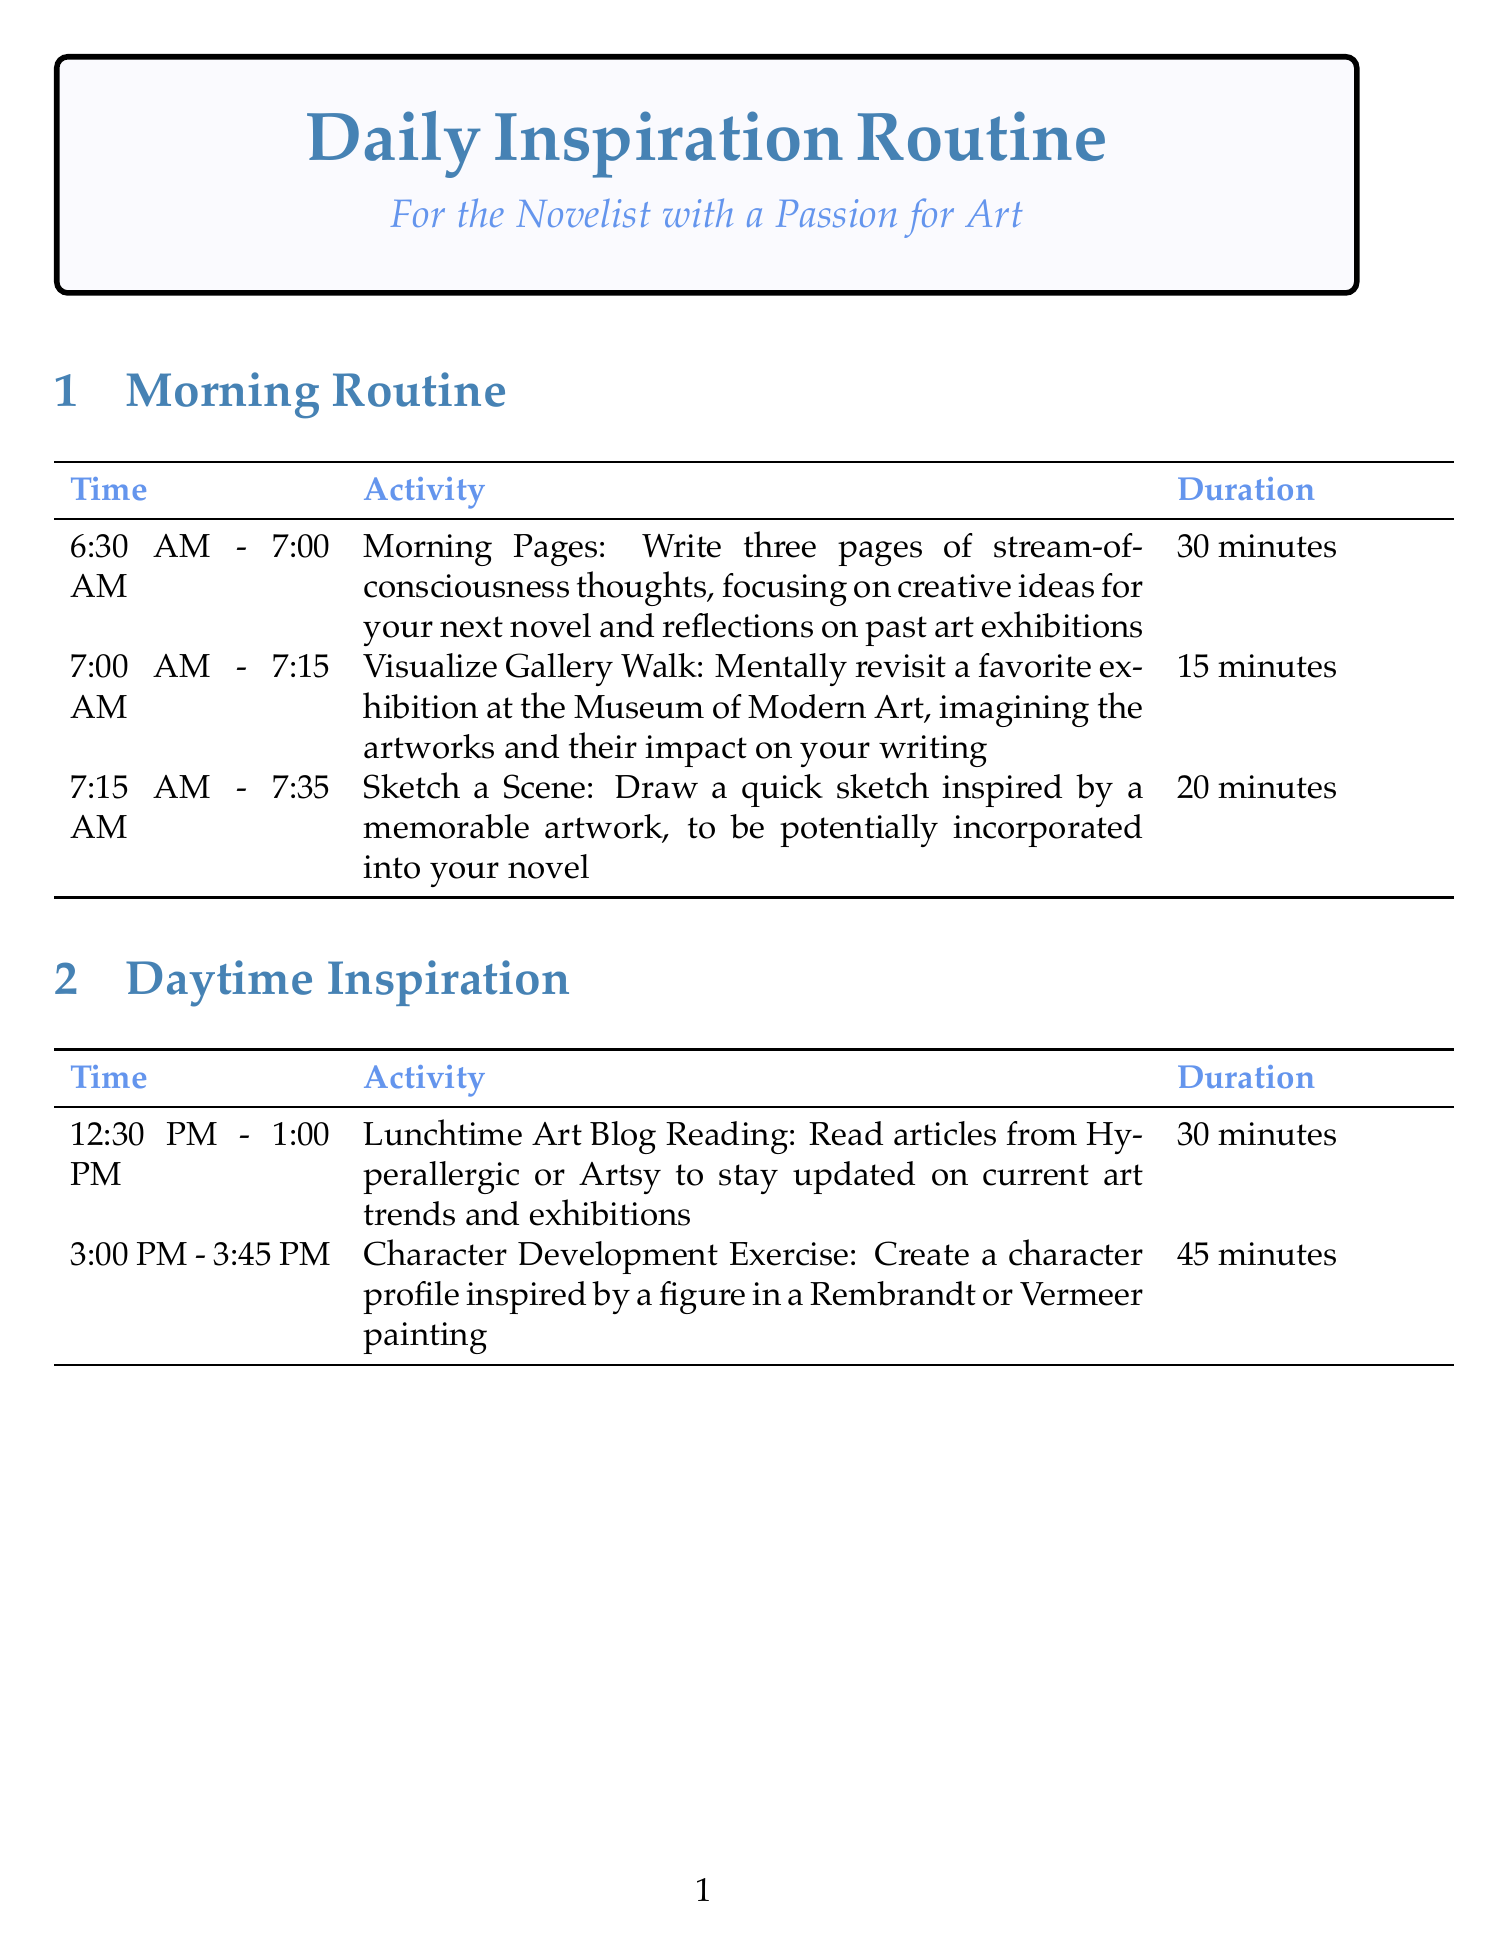What is the duration of Morning Pages? The duration of Morning Pages is specified in the morning routine section of the document as 30 minutes.
Answer: 30 minutes At what time does the Daily Writing Review start? The start time for Daily Writing Review is listed in the evening reflection section of the document.
Answer: 7:00 PM What activity follows Gratitude Journaling? The activity that follows Gratitude Journaling is detailed in the evening reflection section and involves planning.
Answer: Next Day Planning How long is the Virtual Gallery Tour? The duration for the Virtual Gallery Tour is provided in the evening reflection section of the document as 45 minutes.
Answer: 45 minutes What is the total duration of weekly activities? By adding the durations of Local Gallery Visit (2 hours) and Art Book Review (1 hour), the total duration of weekly activities can be found.
Answer: 3 hours Which two paintings inspire the Character Development Exercise? The Character Development Exercise is based on figures from two specific artists that are mentioned in the daytime inspiration section.
Answer: Rembrandt or Vermeer 